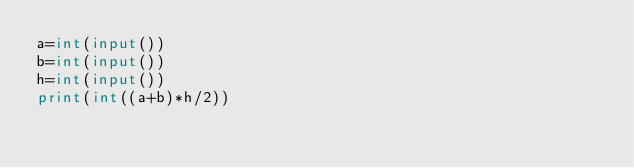<code> <loc_0><loc_0><loc_500><loc_500><_Python_>a=int(input())
b=int(input())
h=int(input())
print(int((a+b)*h/2))</code> 